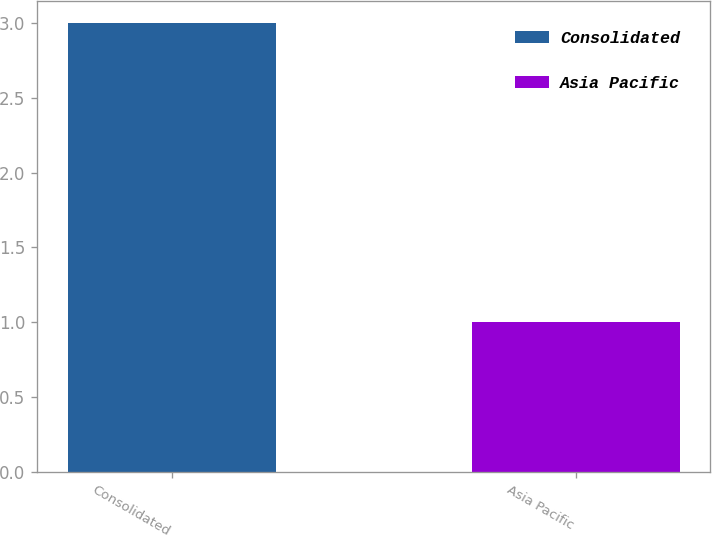<chart> <loc_0><loc_0><loc_500><loc_500><bar_chart><fcel>Consolidated<fcel>Asia Pacific<nl><fcel>3<fcel>1<nl></chart> 